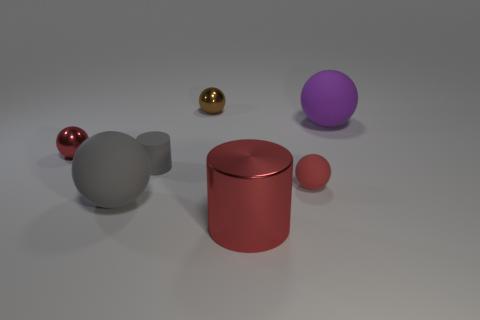What number of other objects are the same size as the purple sphere?
Your response must be concise. 2. There is a brown ball; are there any metal cylinders left of it?
Your response must be concise. No. Is the color of the tiny rubber cylinder the same as the small shiny thing that is to the left of the small brown thing?
Ensure brevity in your answer.  No. The rubber ball that is behind the gray matte thing that is behind the big sphere left of the red shiny cylinder is what color?
Keep it short and to the point. Purple. Is there another thing of the same shape as the big gray matte thing?
Your answer should be compact. Yes. There is a shiny cylinder that is the same size as the gray rubber sphere; what color is it?
Your answer should be compact. Red. There is a large ball left of the tiny matte sphere; what is its material?
Provide a short and direct response. Rubber. There is a tiny metal object that is on the left side of the tiny matte cylinder; does it have the same shape as the tiny red object that is right of the large red object?
Keep it short and to the point. Yes. Is the number of tiny red balls that are on the left side of the tiny gray thing the same as the number of red objects?
Your answer should be very brief. No. How many large purple objects are made of the same material as the big purple ball?
Provide a short and direct response. 0. 